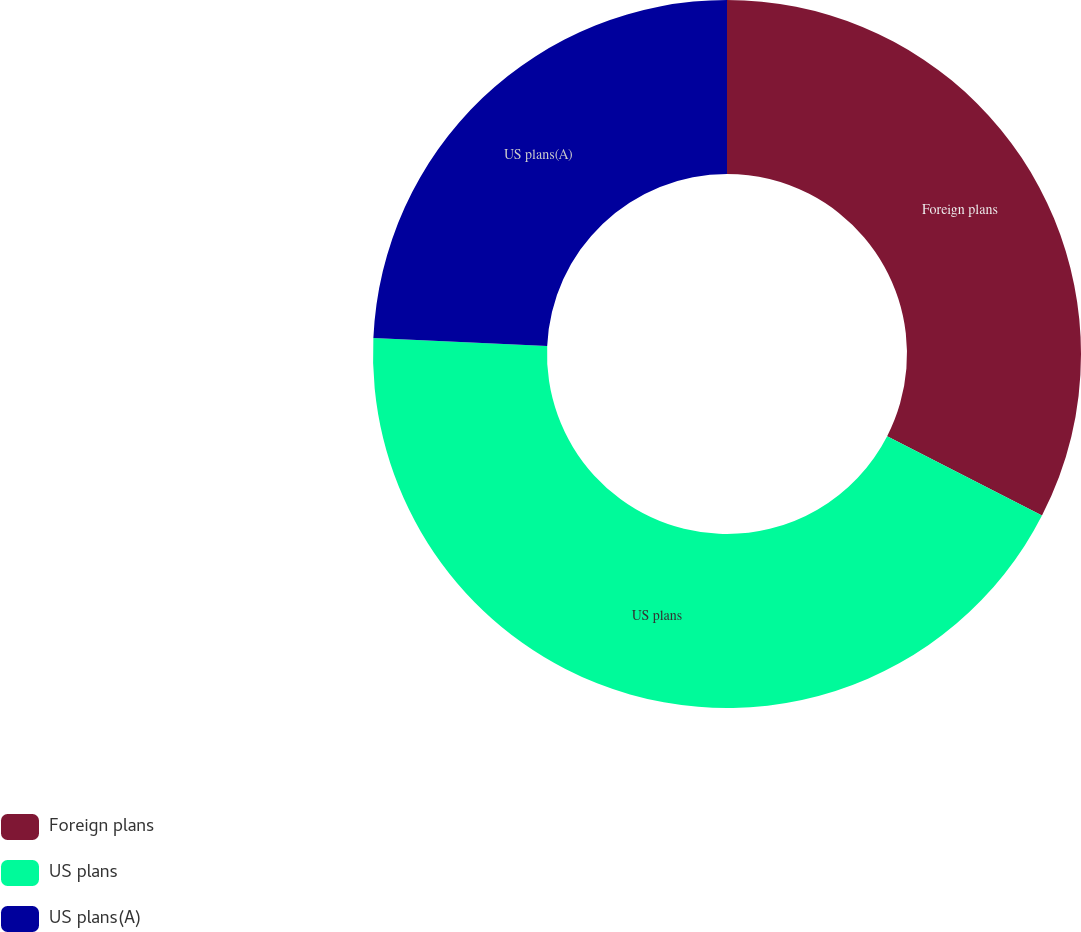Convert chart to OTSL. <chart><loc_0><loc_0><loc_500><loc_500><pie_chart><fcel>Foreign plans<fcel>US plans<fcel>US plans(A)<nl><fcel>32.54%<fcel>43.17%<fcel>24.28%<nl></chart> 